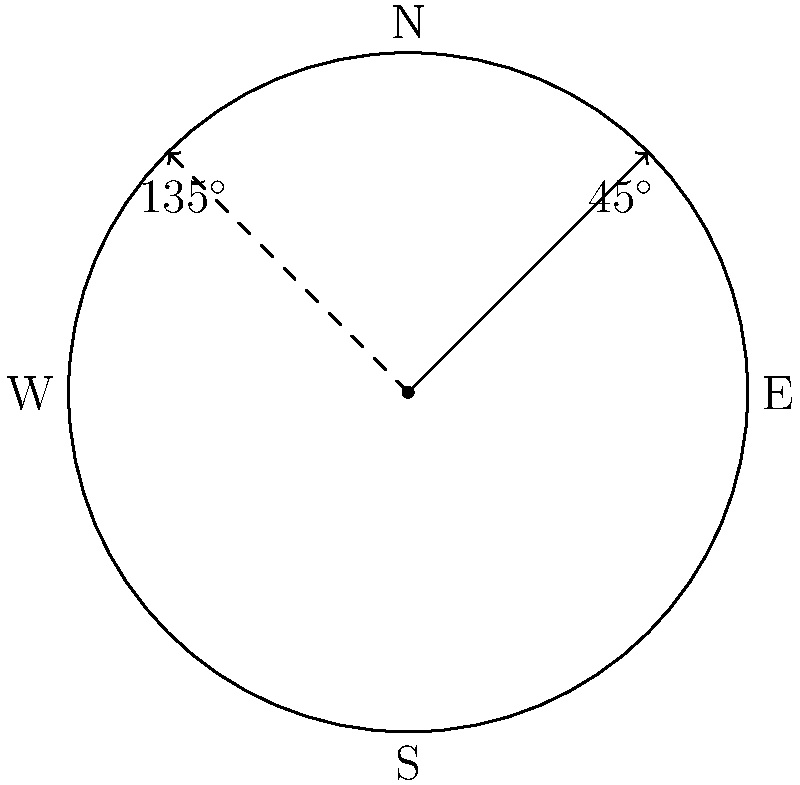In a post-apocalyptic landscape, an author's protagonist uses a compass rose to navigate. The character starts facing 45° northeast and needs to rotate 90° counterclockwise to face a new direction. What is the new heading in degrees, and how might this rotation symbolize a pivotal moment in the character's journey through the dystopian world? To solve this problem, we need to follow these steps:

1. Identify the initial heading: 45° (northeast)
2. Determine the rotation: 90° counterclockwise
3. Calculate the new heading:
   - Counterclockwise rotation means we add degrees
   - New heading = Initial heading + Rotation
   - New heading = 45° + 90° = 135°

4. Interpret the result:
   - 135° corresponds to a northwest direction

5. Literary interpretation:
   - The 90° rotation could symbolize a significant change in the character's perspective or journey.
   - Moving from northeast (45°) to northwest (135°) might represent:
     a. A shift from a more optimistic outlook (east) to a more challenging path (west)
     b. A transition from familiar territory to unexplored areas
     c. A metaphorical "turning point" in the character's development or the plot

This transformation in direction aligns with the theme of revolution in the dystopian genre, potentially marking a crucial moment where the protagonist faces new challenges or gains a different understanding of their world.
Answer: 135° northwest 